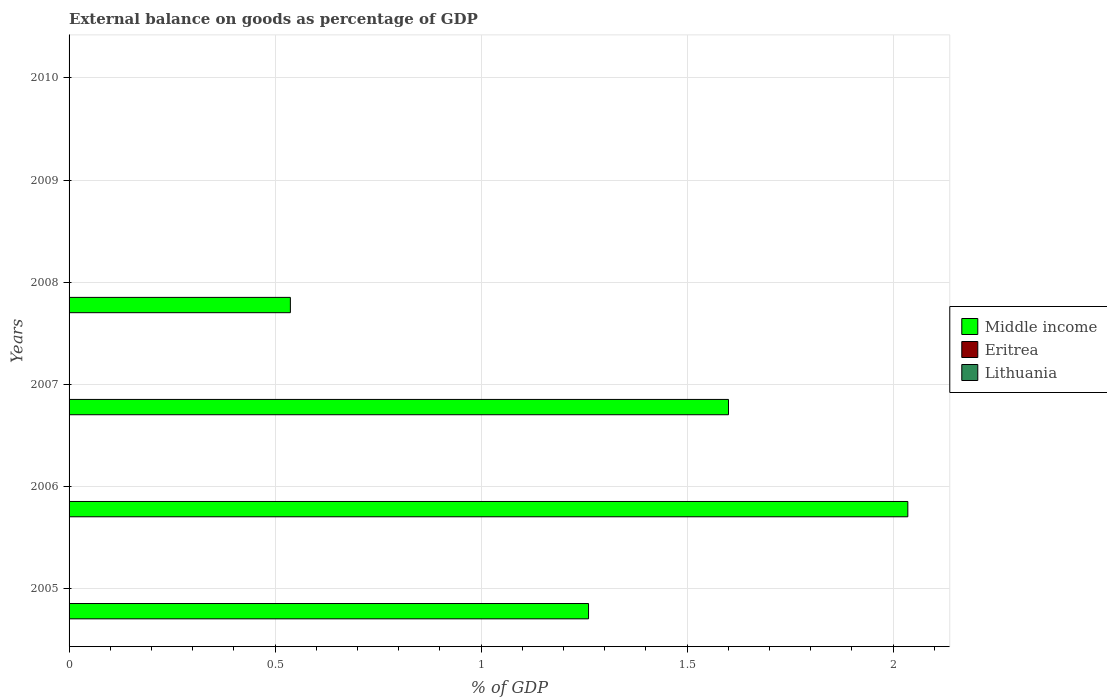Are the number of bars per tick equal to the number of legend labels?
Provide a short and direct response. No. Are the number of bars on each tick of the Y-axis equal?
Keep it short and to the point. No. How many bars are there on the 4th tick from the bottom?
Your answer should be compact. 1. In how many cases, is the number of bars for a given year not equal to the number of legend labels?
Provide a short and direct response. 6. What is the external balance on goods as percentage of GDP in Lithuania in 2008?
Ensure brevity in your answer.  0. Across all years, what is the maximum external balance on goods as percentage of GDP in Middle income?
Your answer should be very brief. 2.04. Across all years, what is the minimum external balance on goods as percentage of GDP in Lithuania?
Offer a very short reply. 0. What is the difference between the external balance on goods as percentage of GDP in Middle income in 2007 and that in 2008?
Your response must be concise. 1.06. What is the difference between the external balance on goods as percentage of GDP in Eritrea in 2010 and the external balance on goods as percentage of GDP in Lithuania in 2005?
Make the answer very short. 0. In how many years, is the external balance on goods as percentage of GDP in Eritrea greater than 1.6 %?
Offer a terse response. 0. What is the ratio of the external balance on goods as percentage of GDP in Middle income in 2005 to that in 2008?
Provide a succinct answer. 2.35. Is the external balance on goods as percentage of GDP in Middle income in 2006 less than that in 2007?
Your answer should be very brief. No. What is the difference between the highest and the second highest external balance on goods as percentage of GDP in Middle income?
Make the answer very short. 0.44. What is the difference between the highest and the lowest external balance on goods as percentage of GDP in Middle income?
Ensure brevity in your answer.  2.04. Is the sum of the external balance on goods as percentage of GDP in Middle income in 2005 and 2007 greater than the maximum external balance on goods as percentage of GDP in Lithuania across all years?
Offer a terse response. Yes. Is it the case that in every year, the sum of the external balance on goods as percentage of GDP in Eritrea and external balance on goods as percentage of GDP in Middle income is greater than the external balance on goods as percentage of GDP in Lithuania?
Offer a very short reply. No. How many bars are there?
Your response must be concise. 4. Are all the bars in the graph horizontal?
Provide a short and direct response. Yes. How many years are there in the graph?
Provide a short and direct response. 6. What is the difference between two consecutive major ticks on the X-axis?
Your answer should be compact. 0.5. Does the graph contain any zero values?
Make the answer very short. Yes. Does the graph contain grids?
Offer a terse response. Yes. Where does the legend appear in the graph?
Your response must be concise. Center right. What is the title of the graph?
Provide a short and direct response. External balance on goods as percentage of GDP. Does "Guinea" appear as one of the legend labels in the graph?
Your response must be concise. No. What is the label or title of the X-axis?
Offer a terse response. % of GDP. What is the label or title of the Y-axis?
Your answer should be compact. Years. What is the % of GDP of Middle income in 2005?
Your answer should be compact. 1.26. What is the % of GDP in Lithuania in 2005?
Keep it short and to the point. 0. What is the % of GDP of Middle income in 2006?
Make the answer very short. 2.04. What is the % of GDP in Eritrea in 2006?
Your answer should be compact. 0. What is the % of GDP of Middle income in 2007?
Your response must be concise. 1.6. What is the % of GDP of Eritrea in 2007?
Keep it short and to the point. 0. What is the % of GDP of Lithuania in 2007?
Your answer should be compact. 0. What is the % of GDP in Middle income in 2008?
Provide a succinct answer. 0.54. What is the % of GDP in Eritrea in 2008?
Keep it short and to the point. 0. What is the % of GDP in Lithuania in 2009?
Your answer should be compact. 0. What is the % of GDP in Middle income in 2010?
Offer a very short reply. 0. What is the % of GDP of Eritrea in 2010?
Make the answer very short. 0. What is the % of GDP in Lithuania in 2010?
Provide a succinct answer. 0. Across all years, what is the maximum % of GDP in Middle income?
Provide a short and direct response. 2.04. Across all years, what is the minimum % of GDP of Middle income?
Keep it short and to the point. 0. What is the total % of GDP of Middle income in the graph?
Keep it short and to the point. 5.43. What is the difference between the % of GDP of Middle income in 2005 and that in 2006?
Make the answer very short. -0.77. What is the difference between the % of GDP in Middle income in 2005 and that in 2007?
Your answer should be compact. -0.34. What is the difference between the % of GDP of Middle income in 2005 and that in 2008?
Your response must be concise. 0.72. What is the difference between the % of GDP of Middle income in 2006 and that in 2007?
Offer a very short reply. 0.44. What is the difference between the % of GDP of Middle income in 2006 and that in 2008?
Your answer should be compact. 1.5. What is the difference between the % of GDP of Middle income in 2007 and that in 2008?
Your answer should be compact. 1.06. What is the average % of GDP of Middle income per year?
Provide a short and direct response. 0.91. What is the average % of GDP of Eritrea per year?
Your answer should be very brief. 0. What is the ratio of the % of GDP in Middle income in 2005 to that in 2006?
Provide a succinct answer. 0.62. What is the ratio of the % of GDP of Middle income in 2005 to that in 2007?
Ensure brevity in your answer.  0.79. What is the ratio of the % of GDP of Middle income in 2005 to that in 2008?
Offer a very short reply. 2.35. What is the ratio of the % of GDP in Middle income in 2006 to that in 2007?
Provide a succinct answer. 1.27. What is the ratio of the % of GDP in Middle income in 2006 to that in 2008?
Provide a succinct answer. 3.79. What is the ratio of the % of GDP of Middle income in 2007 to that in 2008?
Your answer should be compact. 2.98. What is the difference between the highest and the second highest % of GDP in Middle income?
Your response must be concise. 0.44. What is the difference between the highest and the lowest % of GDP of Middle income?
Your response must be concise. 2.04. 